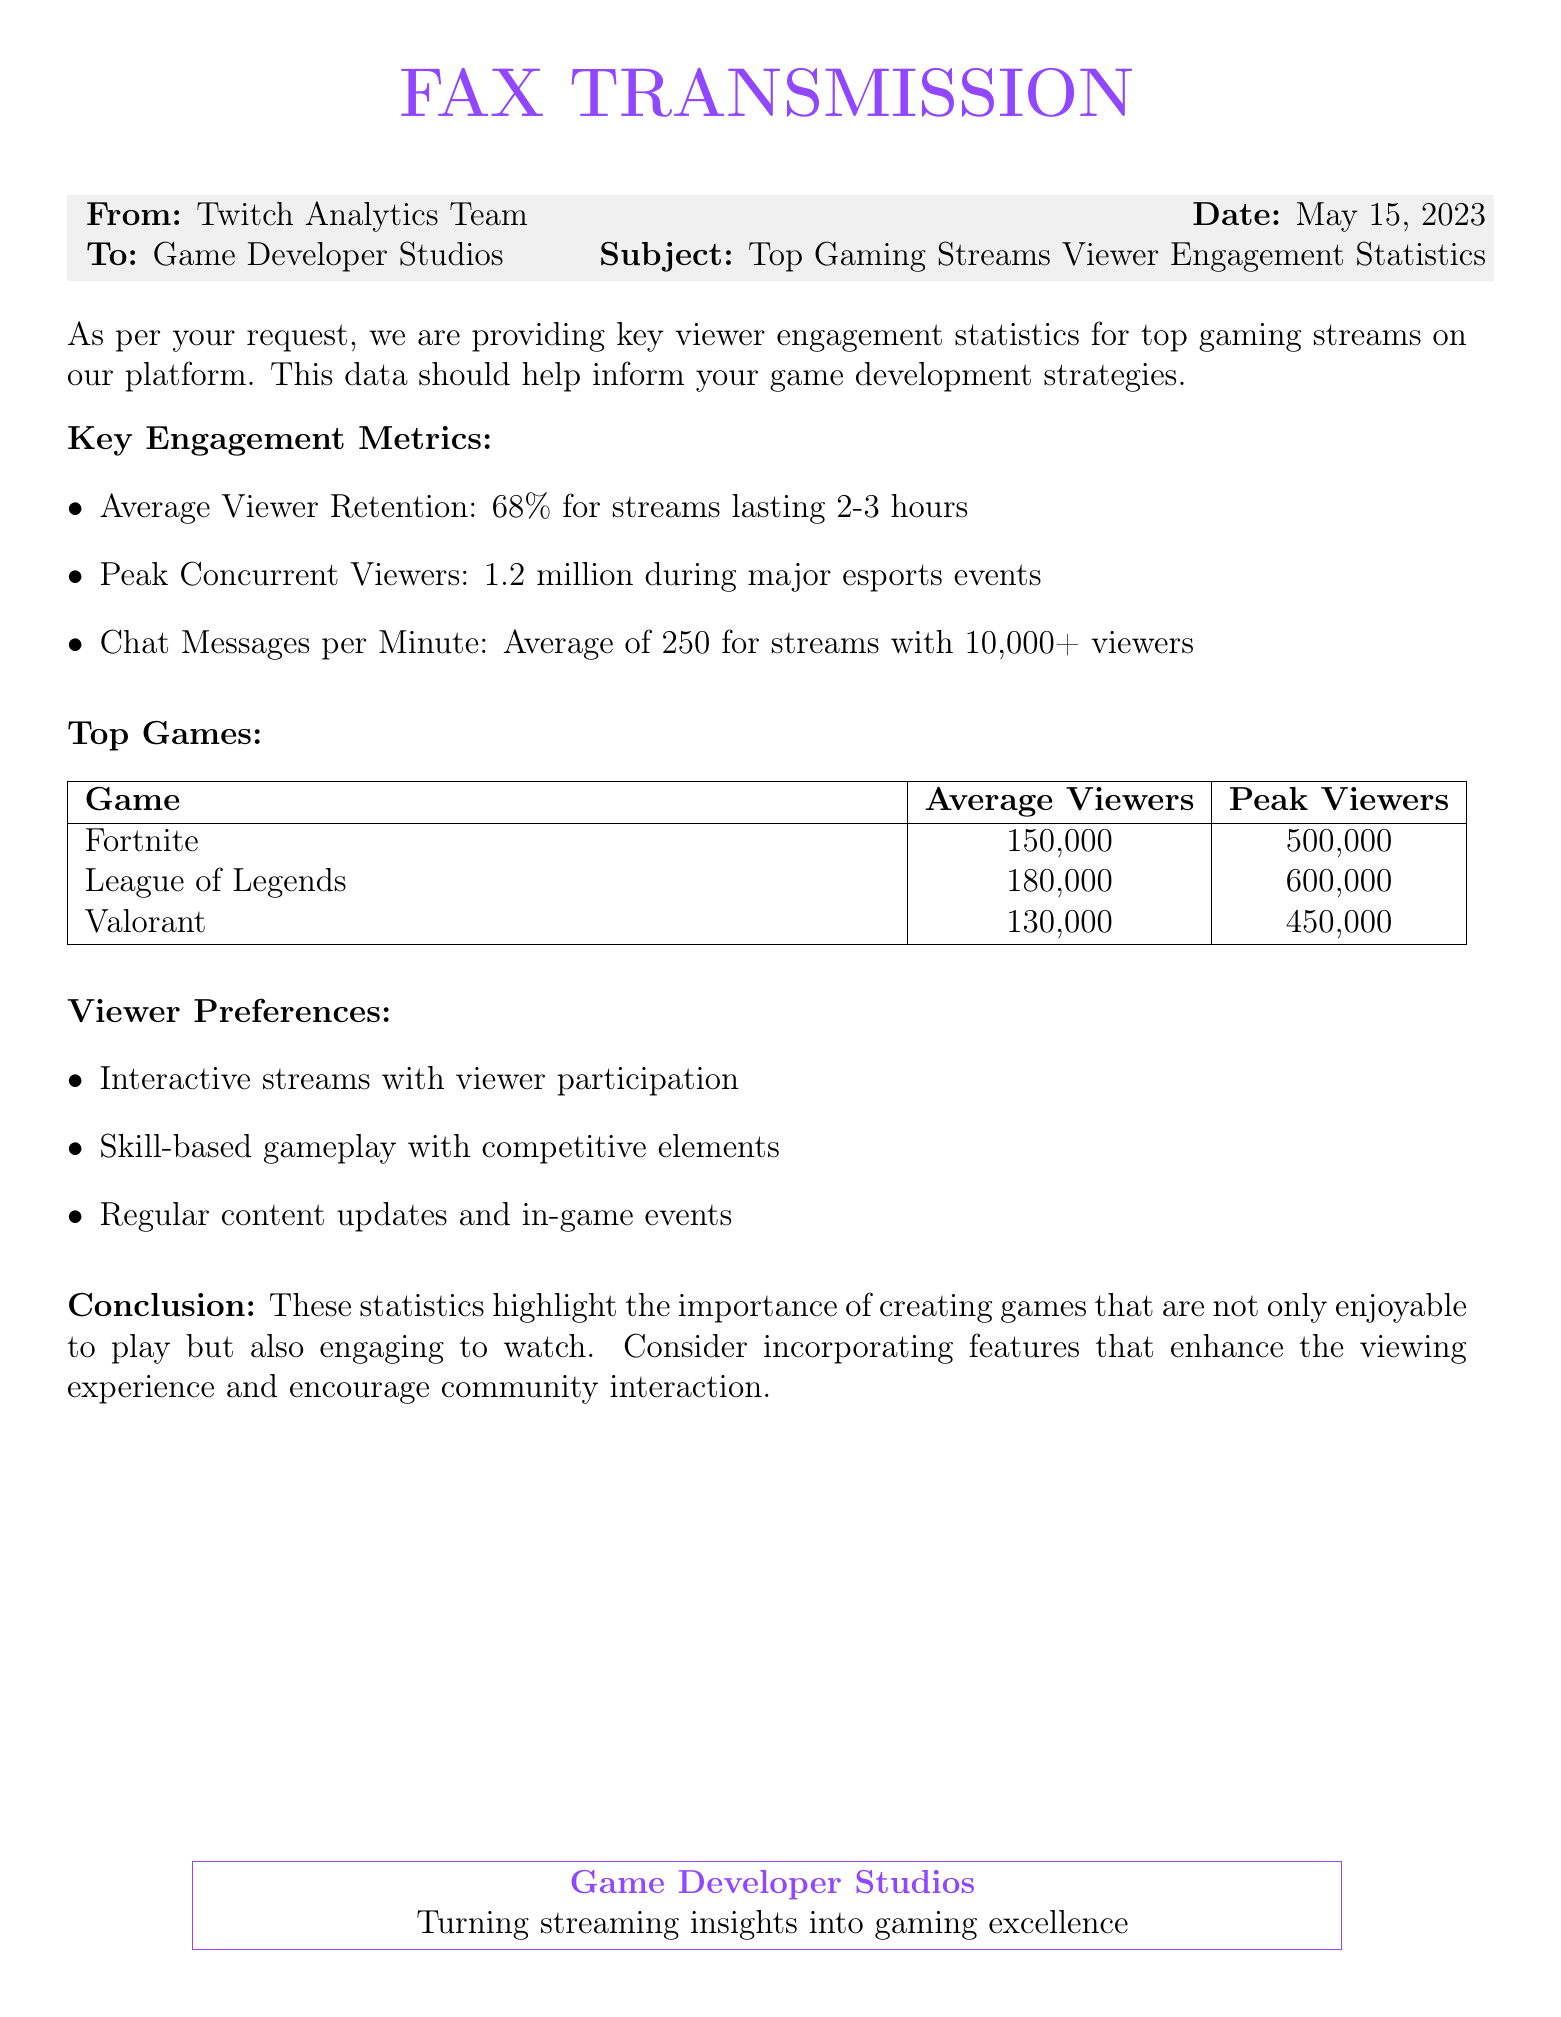what is the average viewer retention? The average viewer retention provided in the document is a key engagement metric, specifically noted as 68%.
Answer: 68% what is the peak concurrent viewers during major esports events? The document states that the peak concurrent viewers during major esports events reached 1.2 million.
Answer: 1.2 million which game has the highest average viewers? The document includes a table listing different games and their average viewers, with League of Legends having the highest average at 180,000.
Answer: League of Legends what type of gameplay do viewers prefer according to the document? The viewer preferences section outlines multiple aspects, with "skill-based gameplay with competitive elements" being a prominent preference noted.
Answer: Skill-based gameplay with competitive elements what is the date on the fax? The date on the fax is specified clearly in the document as May 15, 2023.
Answer: May 15, 2023 which platform is the source of this document? The document mentions the source as the Twitch Analytics Team, indicating the platform is Twitch.
Answer: Twitch how many chat messages per minute are typical for streams with 10,000+ viewers? According to the viewer engagement statistics, the average chat messages per minute for those streams is noted as 250.
Answer: 250 what is the conclusion provided in the fax? The conclusion summarizes the importance of creating engaging games, stating specifically, "These statistics highlight the importance of creating games that are not only enjoyable to play but also engaging to watch."
Answer: Engaging to watch what is the subject of the fax? The subject line of the fax indicates that the focus is on "Top Gaming Streams Viewer Engagement Statistics."
Answer: Top Gaming Streams Viewer Engagement Statistics 